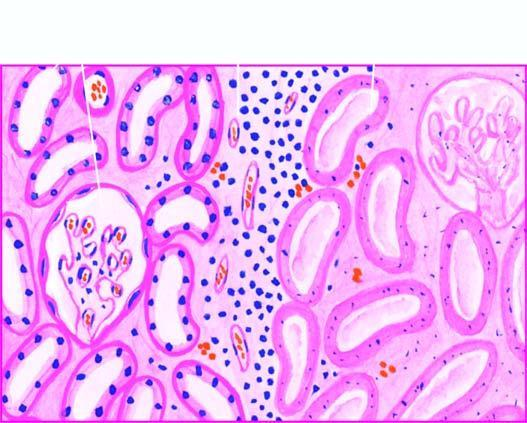does the interface between viable and non-viable area show non-specific chronic inflammation and proliferating vessels?
Answer the question using a single word or phrase. Yes 